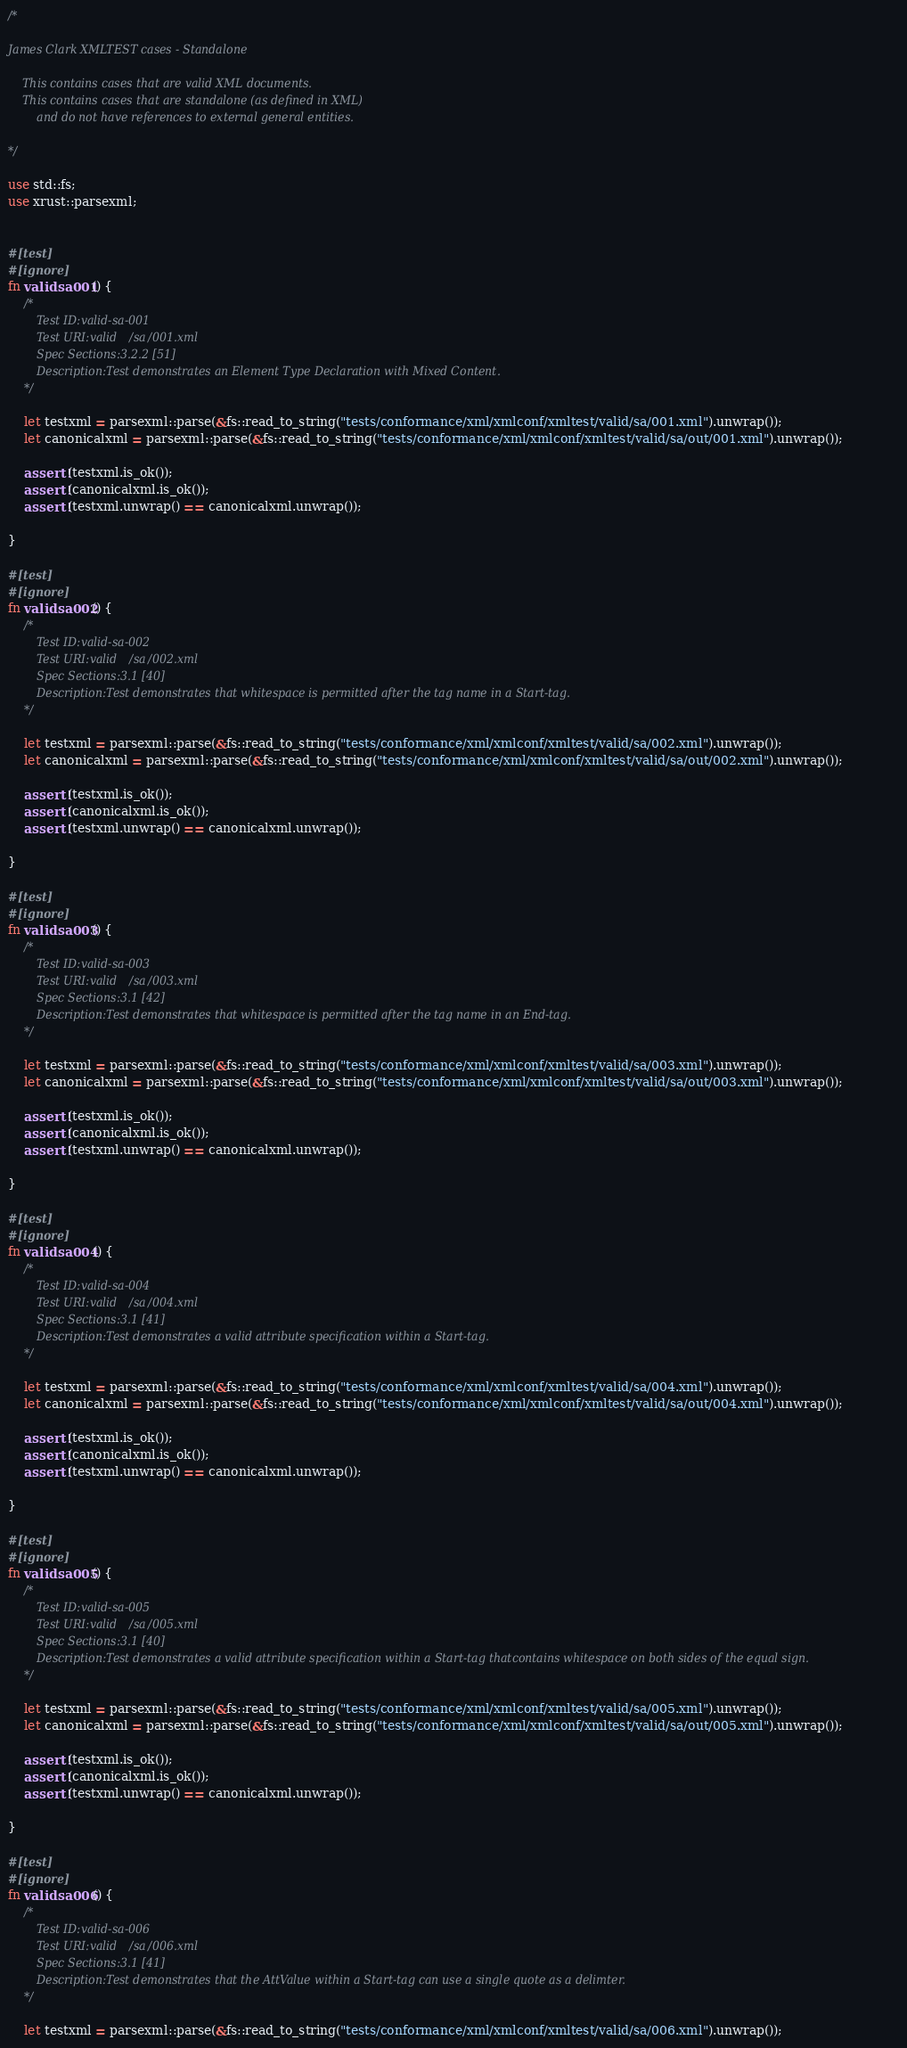Convert code to text. <code><loc_0><loc_0><loc_500><loc_500><_Rust_>/*

James Clark XMLTEST cases - Standalone

    This contains cases that are valid XML documents.
    This contains cases that are standalone (as defined in XML)
        and do not have references to external general entities.

*/

use std::fs;
use xrust::parsexml;


#[test]
#[ignore]
fn validsa001() {
    /*
        Test ID:valid-sa-001
        Test URI:valid/sa/001.xml
        Spec Sections:3.2.2 [51]
        Description:Test demonstrates an Element Type Declaration with Mixed Content.
    */

    let testxml = parsexml::parse(&fs::read_to_string("tests/conformance/xml/xmlconf/xmltest/valid/sa/001.xml").unwrap());
    let canonicalxml = parsexml::parse(&fs::read_to_string("tests/conformance/xml/xmlconf/xmltest/valid/sa/out/001.xml").unwrap());

    assert!(testxml.is_ok());
    assert!(canonicalxml.is_ok());
    assert!(testxml.unwrap() == canonicalxml.unwrap());

}

#[test]
#[ignore]
fn validsa002() {
    /*
        Test ID:valid-sa-002
        Test URI:valid/sa/002.xml
        Spec Sections:3.1 [40]
        Description:Test demonstrates that whitespace is permitted after the tag name in a Start-tag.
    */

    let testxml = parsexml::parse(&fs::read_to_string("tests/conformance/xml/xmlconf/xmltest/valid/sa/002.xml").unwrap());
    let canonicalxml = parsexml::parse(&fs::read_to_string("tests/conformance/xml/xmlconf/xmltest/valid/sa/out/002.xml").unwrap());

    assert!(testxml.is_ok());
    assert!(canonicalxml.is_ok());
    assert!(testxml.unwrap() == canonicalxml.unwrap());

}

#[test]
#[ignore]
fn validsa003() {
    /*
        Test ID:valid-sa-003
        Test URI:valid/sa/003.xml
        Spec Sections:3.1 [42]
        Description:Test demonstrates that whitespace is permitted after the tag name in an End-tag.
    */

    let testxml = parsexml::parse(&fs::read_to_string("tests/conformance/xml/xmlconf/xmltest/valid/sa/003.xml").unwrap());
    let canonicalxml = parsexml::parse(&fs::read_to_string("tests/conformance/xml/xmlconf/xmltest/valid/sa/out/003.xml").unwrap());

    assert!(testxml.is_ok());
    assert!(canonicalxml.is_ok());
    assert!(testxml.unwrap() == canonicalxml.unwrap());

}

#[test]
#[ignore]
fn validsa004() {
    /*
        Test ID:valid-sa-004
        Test URI:valid/sa/004.xml
        Spec Sections:3.1 [41]
        Description:Test demonstrates a valid attribute specification within a Start-tag.
    */

    let testxml = parsexml::parse(&fs::read_to_string("tests/conformance/xml/xmlconf/xmltest/valid/sa/004.xml").unwrap());
    let canonicalxml = parsexml::parse(&fs::read_to_string("tests/conformance/xml/xmlconf/xmltest/valid/sa/out/004.xml").unwrap());

    assert!(testxml.is_ok());
    assert!(canonicalxml.is_ok());
    assert!(testxml.unwrap() == canonicalxml.unwrap());

}

#[test]
#[ignore]
fn validsa005() {
    /*
        Test ID:valid-sa-005
        Test URI:valid/sa/005.xml
        Spec Sections:3.1 [40]
        Description:Test demonstrates a valid attribute specification within a Start-tag thatcontains whitespace on both sides of the equal sign.
    */

    let testxml = parsexml::parse(&fs::read_to_string("tests/conformance/xml/xmlconf/xmltest/valid/sa/005.xml").unwrap());
    let canonicalxml = parsexml::parse(&fs::read_to_string("tests/conformance/xml/xmlconf/xmltest/valid/sa/out/005.xml").unwrap());

    assert!(testxml.is_ok());
    assert!(canonicalxml.is_ok());
    assert!(testxml.unwrap() == canonicalxml.unwrap());

}

#[test]
#[ignore]
fn validsa006() {
    /*
        Test ID:valid-sa-006
        Test URI:valid/sa/006.xml
        Spec Sections:3.1 [41]
        Description:Test demonstrates that the AttValue within a Start-tag can use a single quote as a delimter.
    */

    let testxml = parsexml::parse(&fs::read_to_string("tests/conformance/xml/xmlconf/xmltest/valid/sa/006.xml").unwrap());</code> 